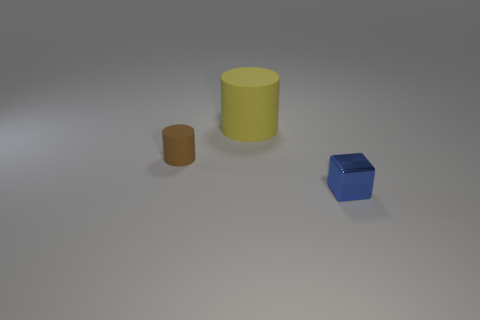There is a thing that is on the left side of the tiny metal cube and in front of the big rubber cylinder; what is it made of?
Your answer should be very brief. Rubber. Is there anything else that is the same shape as the big thing?
Your response must be concise. Yes. There is a thing that is the same material as the big cylinder; what color is it?
Give a very brief answer. Brown. How many things are either blue cubes or yellow matte objects?
Your response must be concise. 2. Do the blue thing and the object behind the tiny brown rubber thing have the same size?
Your answer should be very brief. No. What color is the thing that is left of the rubber cylinder that is right of the rubber cylinder left of the big object?
Provide a short and direct response. Brown. The big cylinder is what color?
Keep it short and to the point. Yellow. Is the number of big yellow rubber things behind the blue thing greater than the number of brown cylinders that are behind the brown matte cylinder?
Offer a very short reply. Yes. Is the shape of the tiny matte object the same as the thing behind the small brown matte object?
Offer a terse response. Yes. Do the cylinder on the right side of the small rubber object and the object to the left of the large rubber object have the same size?
Provide a succinct answer. No. 